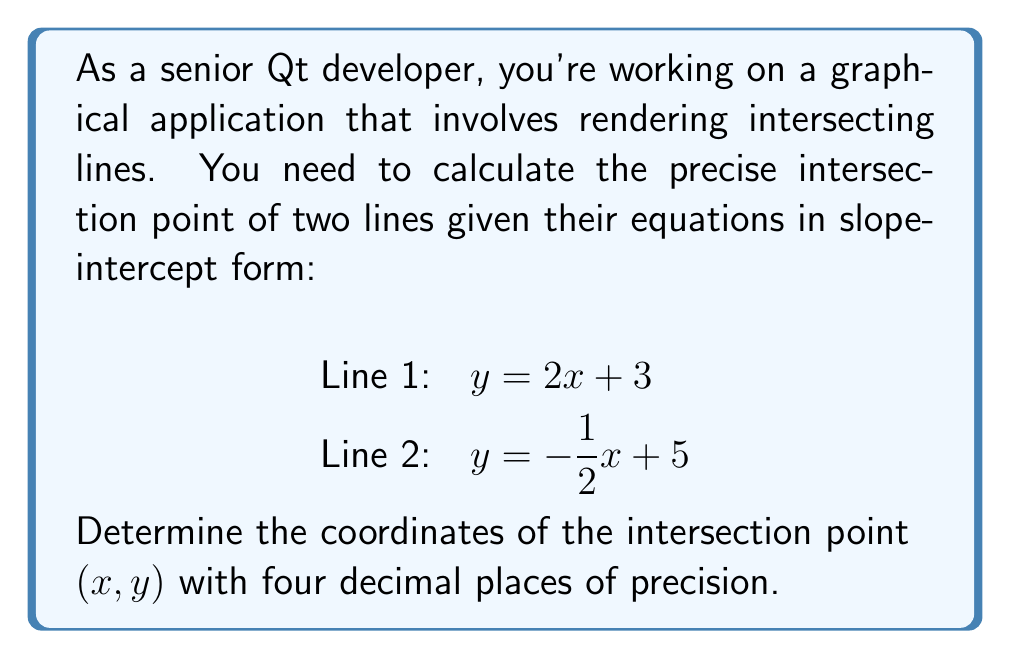Can you answer this question? To find the intersection point of two lines given in slope-intercept form, we follow these steps:

1. Set the equations equal to each other:
   $$2x + 3 = -\frac{1}{2}x + 5$$

2. Solve for x:
   $$2x + 3 = -\frac{1}{2}x + 5$$
   $$2x + \frac{1}{2}x = 5 - 3$$
   $$\frac{5}{2}x = 2$$
   $$x = \frac{4}{5} = 0.8000$$

3. Substitute the x-value into either of the original equations to find y:
   Using Line 1: $y = 2x + 3$
   $$y = 2(0.8000) + 3$$
   $$y = 1.6000 + 3 = 4.6000$$

4. Express the intersection point as an ordered pair $(x, y)$:
   $$(0.8000, 4.6000)$$

To verify, we can substitute these coordinates into both original equations:

Line 1: $4.6000 = 2(0.8000) + 3 = 1.6000 + 3 = 4.6000$ (True)
Line 2: $4.6000 = -\frac{1}{2}(0.8000) + 5 = -0.4000 + 5 = 4.6000$ (True)

Both equations are satisfied, confirming our solution.
Answer: The intersection point of the two lines is $(0.8000, 4.6000)$. 